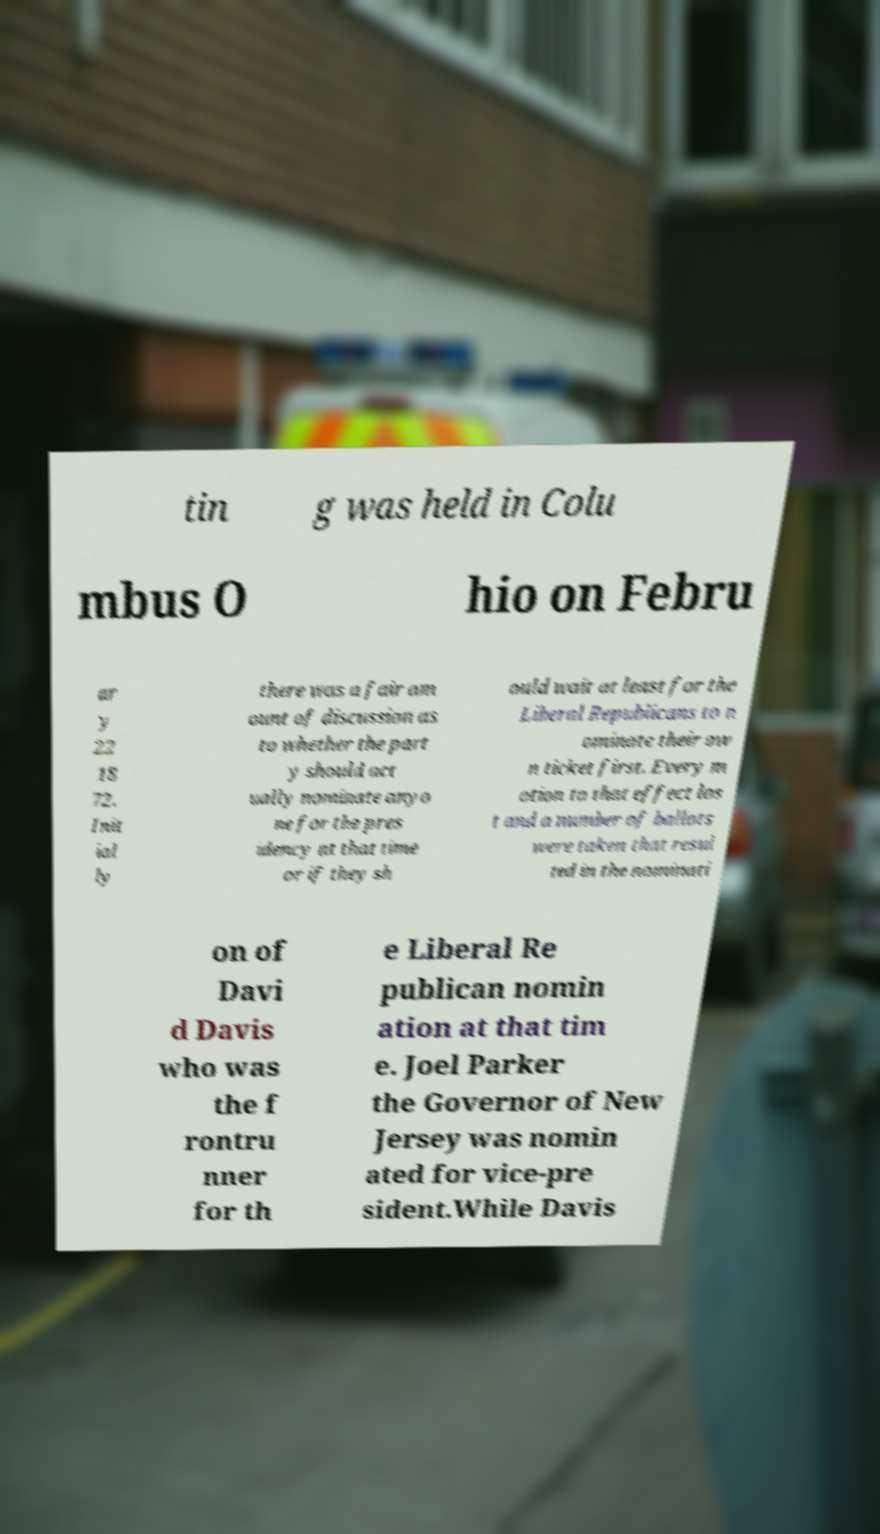There's text embedded in this image that I need extracted. Can you transcribe it verbatim? tin g was held in Colu mbus O hio on Febru ar y 22 18 72. Init ial ly there was a fair am ount of discussion as to whether the part y should act ually nominate anyo ne for the pres idency at that time or if they sh ould wait at least for the Liberal Republicans to n ominate their ow n ticket first. Every m otion to that effect los t and a number of ballots were taken that resul ted in the nominati on of Davi d Davis who was the f rontru nner for th e Liberal Re publican nomin ation at that tim e. Joel Parker the Governor of New Jersey was nomin ated for vice-pre sident.While Davis 